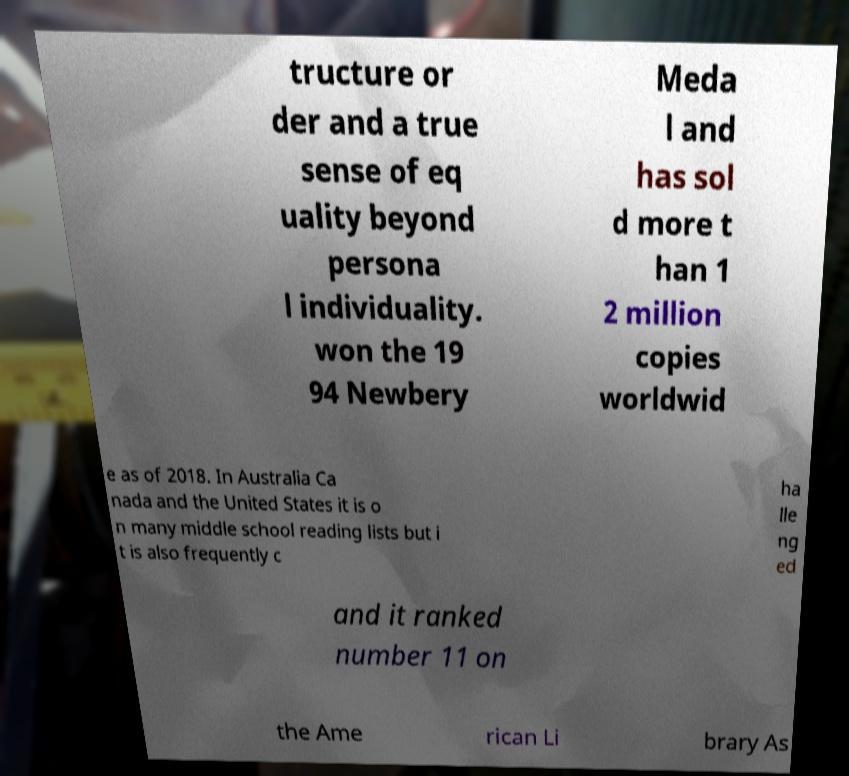What messages or text are displayed in this image? I need them in a readable, typed format. tructure or der and a true sense of eq uality beyond persona l individuality. won the 19 94 Newbery Meda l and has sol d more t han 1 2 million copies worldwid e as of 2018. In Australia Ca nada and the United States it is o n many middle school reading lists but i t is also frequently c ha lle ng ed and it ranked number 11 on the Ame rican Li brary As 